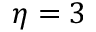<formula> <loc_0><loc_0><loc_500><loc_500>\eta = 3</formula> 